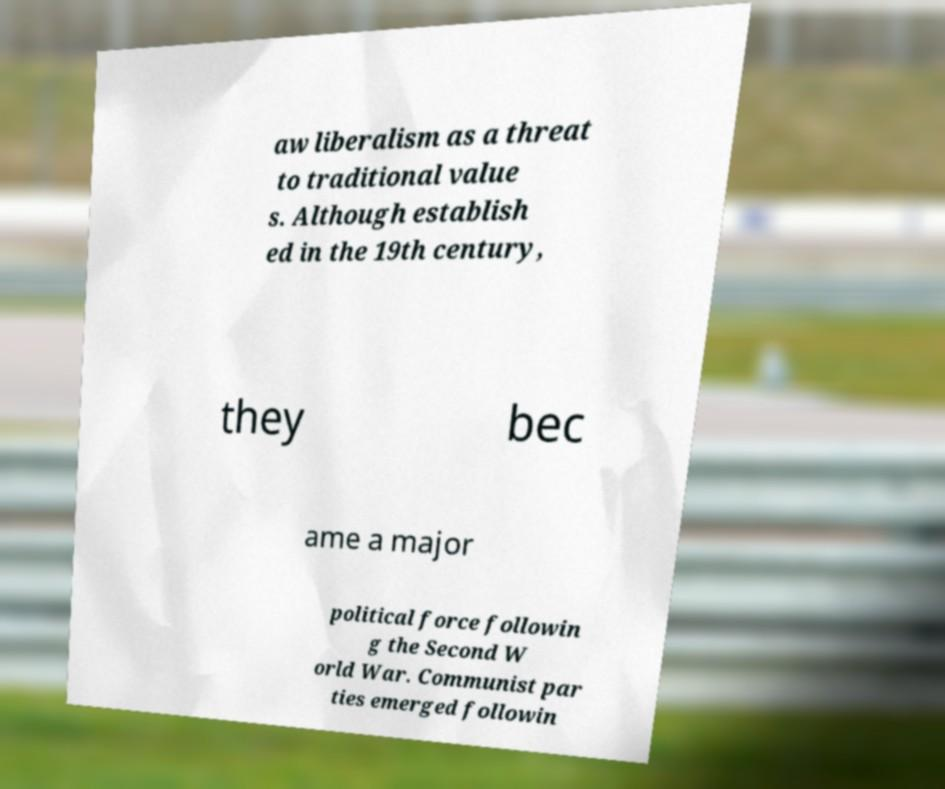Could you assist in decoding the text presented in this image and type it out clearly? aw liberalism as a threat to traditional value s. Although establish ed in the 19th century, they bec ame a major political force followin g the Second W orld War. Communist par ties emerged followin 